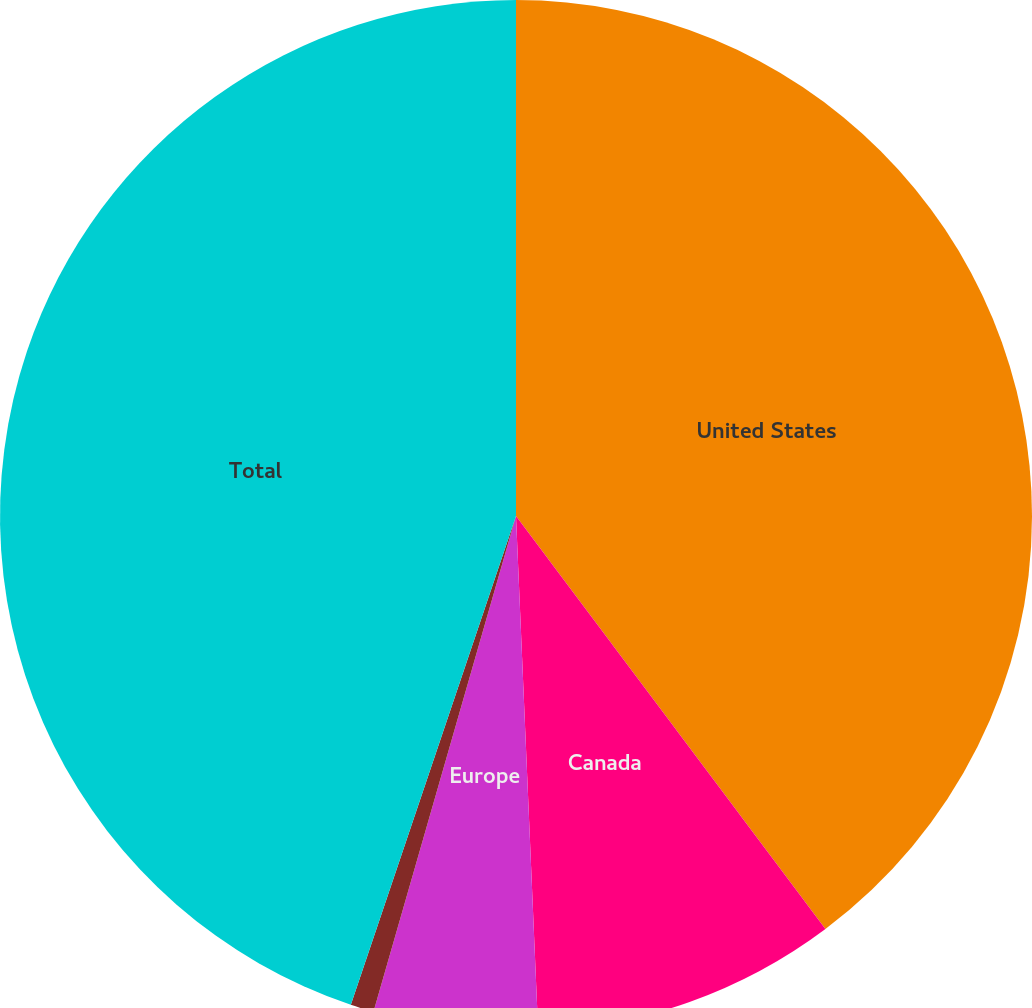Convert chart to OTSL. <chart><loc_0><loc_0><loc_500><loc_500><pie_chart><fcel>United States<fcel>Canada<fcel>Europe<fcel>Other<fcel>Total<nl><fcel>39.76%<fcel>9.55%<fcel>5.14%<fcel>0.73%<fcel>44.81%<nl></chart> 